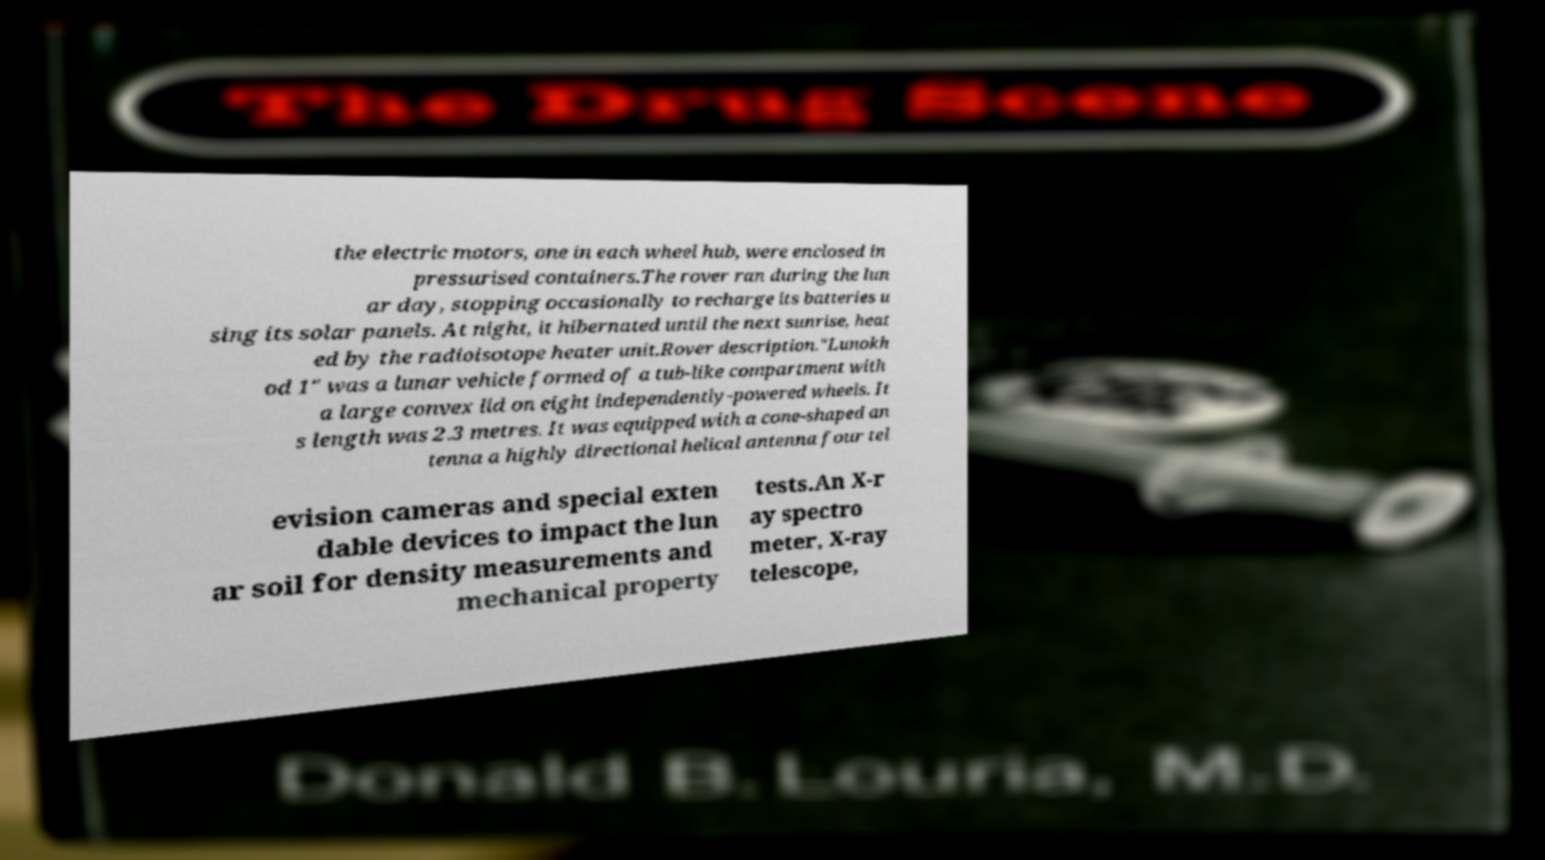Could you assist in decoding the text presented in this image and type it out clearly? the electric motors, one in each wheel hub, were enclosed in pressurised containers.The rover ran during the lun ar day, stopping occasionally to recharge its batteries u sing its solar panels. At night, it hibernated until the next sunrise, heat ed by the radioisotope heater unit.Rover description."Lunokh od 1" was a lunar vehicle formed of a tub-like compartment with a large convex lid on eight independently-powered wheels. It s length was 2.3 metres. It was equipped with a cone-shaped an tenna a highly directional helical antenna four tel evision cameras and special exten dable devices to impact the lun ar soil for density measurements and mechanical property tests.An X-r ay spectro meter, X-ray telescope, 